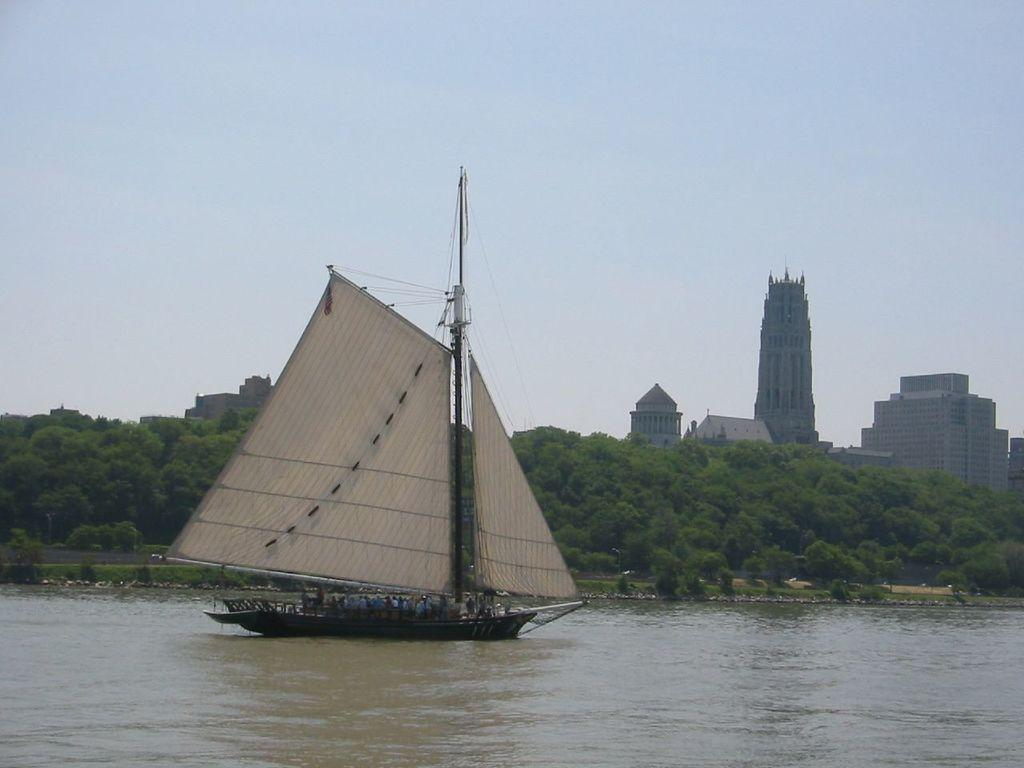What is the main subject in the water in the image? There is a ship in the water in the image. What else can be seen in the image besides the ship? There are buildings and trees visible in the image. What is visible in the sky in the image? The sky is visible in the image. What type of skirt can be seen hanging from the ship's mast in the image? There is no skirt present in the image; it features a ship in the water with buildings, trees, and the sky visible. How many cows are grazing on the shore in the image? There are no cows present in the image; it features a ship in the water with buildings, trees, and the sky visible. 